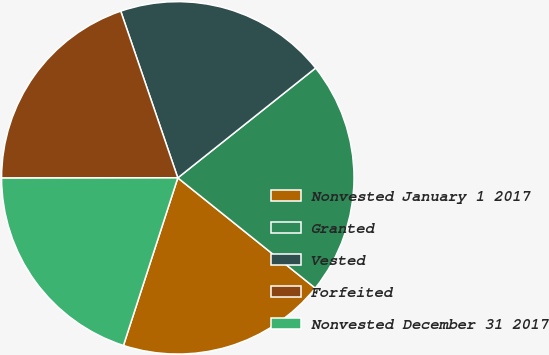Convert chart to OTSL. <chart><loc_0><loc_0><loc_500><loc_500><pie_chart><fcel>Nonvested January 1 2017<fcel>Granted<fcel>Vested<fcel>Forfeited<fcel>Nonvested December 31 2017<nl><fcel>19.23%<fcel>21.47%<fcel>19.54%<fcel>19.77%<fcel>19.99%<nl></chart> 